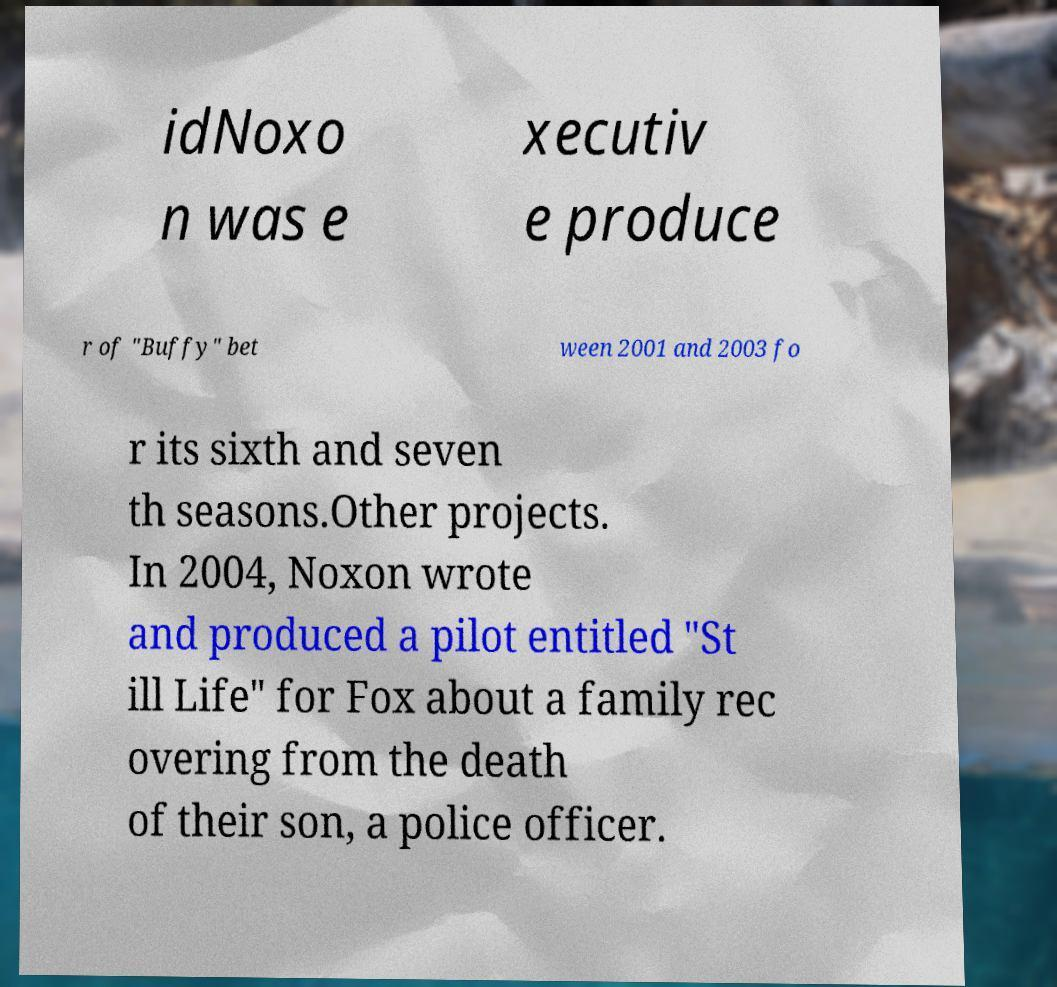What messages or text are displayed in this image? I need them in a readable, typed format. idNoxo n was e xecutiv e produce r of "Buffy" bet ween 2001 and 2003 fo r its sixth and seven th seasons.Other projects. In 2004, Noxon wrote and produced a pilot entitled "St ill Life" for Fox about a family rec overing from the death of their son, a police officer. 